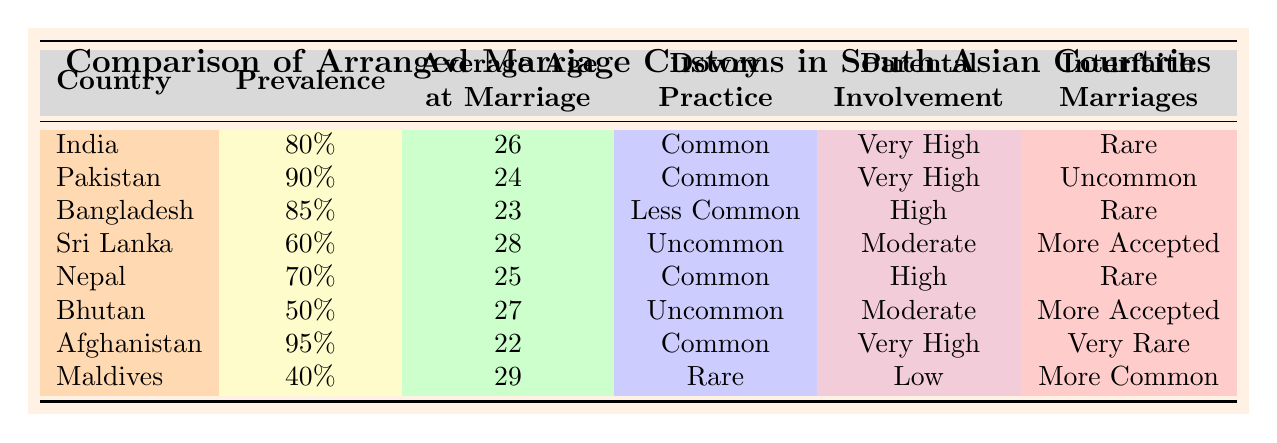What is the average age at marriage in Afghanistan? According to the table, the average age at marriage in Afghanistan is listed as 22 years.
Answer: 22 Which country has the highest prevalence of arranged marriages? The table indicates that Afghanistan has the highest prevalence at 95%.
Answer: Afghanistan Is the dowry practice more common in India or Sri Lanka? The table shows that dowry practice is classified as "Common" in India and "Uncommon" in Sri Lanka, so it is more common in India.
Answer: India How many countries have both high parental involvement and a common dowry practice? The table lists India, Pakistan, and Nepal with "Very High" or "High" parental involvement and "Common" dowry practice. Thus, there are three countries.
Answer: 3 Are interfaith marriages more accepted in Bhutan or Sri Lanka? Bhutan has "More Accepted" interfaith marriages while Sri Lanka has "More Accepted" as well, making it equal.
Answer: Equal What is the difference in average marriage age between the Maldives and Afghanistan? The average age at marriage in the Maldives is 29, while in Afghanistan it is 22. The difference is 29 - 22 = 7 years.
Answer: 7 Which countries have less common dowry practices? According to the table, Bangladesh, Sri Lanka, and Bhutan have less common dowry practices.
Answer: Bangladesh, Sri Lanka, Bhutan Is the prevalence of arranged marriages in Pakistan greater than that in Nepal? The table shows that the prevalence of arranged marriages in Pakistan is 90% and in Nepal is 70%, so yes, it is greater in Pakistan.
Answer: Yes What percentage of interfaith marriages is uncommon in Pakistan? The table states that interfaith marriages in Pakistan are classified as "Uncommon." Thus, the answer is about their acceptance level, not a percentage.
Answer: Uncommon Which country has the lowest prevalence of arranged marriages according to the table? From the data, the Maldives has the lowest prevalence at 40%.
Answer: Maldives 